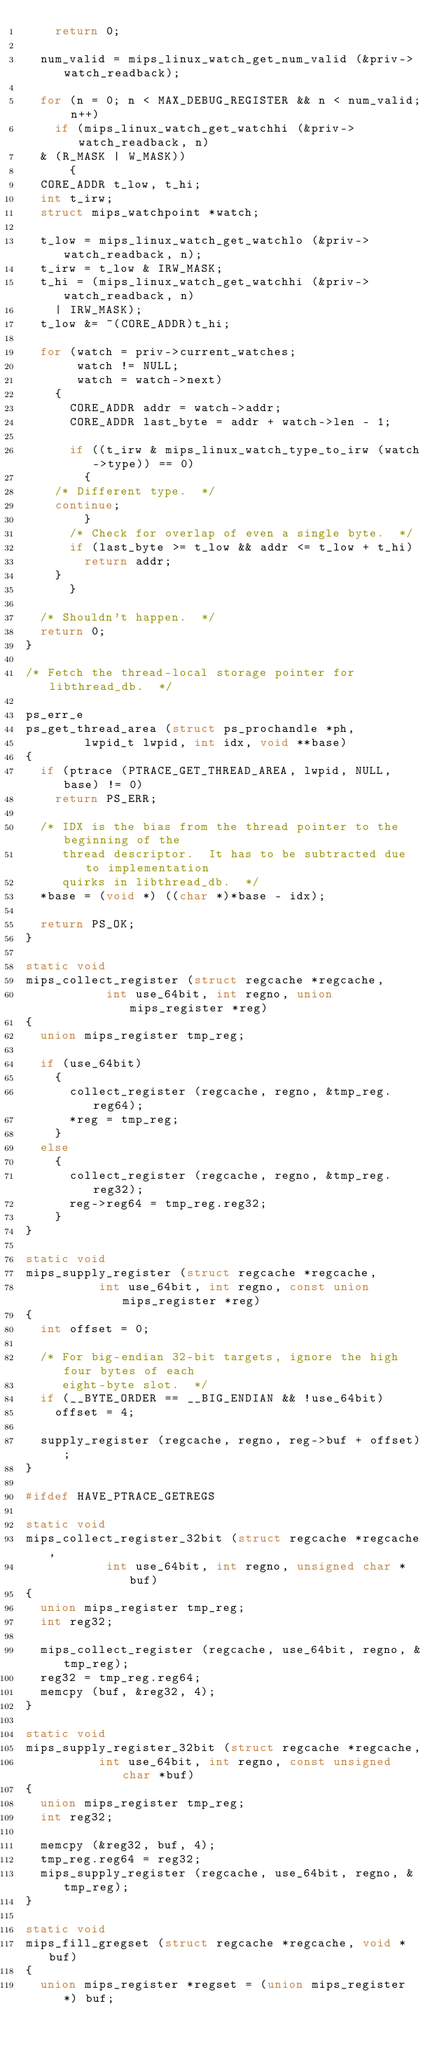<code> <loc_0><loc_0><loc_500><loc_500><_C++_>    return 0;

  num_valid = mips_linux_watch_get_num_valid (&priv->watch_readback);

  for (n = 0; n < MAX_DEBUG_REGISTER && n < num_valid; n++)
    if (mips_linux_watch_get_watchhi (&priv->watch_readback, n)
	& (R_MASK | W_MASK))
      {
	CORE_ADDR t_low, t_hi;
	int t_irw;
	struct mips_watchpoint *watch;

	t_low = mips_linux_watch_get_watchlo (&priv->watch_readback, n);
	t_irw = t_low & IRW_MASK;
	t_hi = (mips_linux_watch_get_watchhi (&priv->watch_readback, n)
		| IRW_MASK);
	t_low &= ~(CORE_ADDR)t_hi;

	for (watch = priv->current_watches;
	     watch != NULL;
	     watch = watch->next)
	  {
	    CORE_ADDR addr = watch->addr;
	    CORE_ADDR last_byte = addr + watch->len - 1;

	    if ((t_irw & mips_linux_watch_type_to_irw (watch->type)) == 0)
	      {
		/* Different type.  */
		continue;
	      }
	    /* Check for overlap of even a single byte.  */
	    if (last_byte >= t_low && addr <= t_low + t_hi)
	      return addr;
	  }
      }

  /* Shouldn't happen.  */
  return 0;
}

/* Fetch the thread-local storage pointer for libthread_db.  */

ps_err_e
ps_get_thread_area (struct ps_prochandle *ph,
		    lwpid_t lwpid, int idx, void **base)
{
  if (ptrace (PTRACE_GET_THREAD_AREA, lwpid, NULL, base) != 0)
    return PS_ERR;

  /* IDX is the bias from the thread pointer to the beginning of the
     thread descriptor.  It has to be subtracted due to implementation
     quirks in libthread_db.  */
  *base = (void *) ((char *)*base - idx);

  return PS_OK;
}

static void
mips_collect_register (struct regcache *regcache,
		       int use_64bit, int regno, union mips_register *reg)
{
  union mips_register tmp_reg;

  if (use_64bit)
    {
      collect_register (regcache, regno, &tmp_reg.reg64);
      *reg = tmp_reg;
    }
  else
    {
      collect_register (regcache, regno, &tmp_reg.reg32);
      reg->reg64 = tmp_reg.reg32;
    }
}

static void
mips_supply_register (struct regcache *regcache,
		      int use_64bit, int regno, const union mips_register *reg)
{
  int offset = 0;

  /* For big-endian 32-bit targets, ignore the high four bytes of each
     eight-byte slot.  */
  if (__BYTE_ORDER == __BIG_ENDIAN && !use_64bit)
    offset = 4;

  supply_register (regcache, regno, reg->buf + offset);
}

#ifdef HAVE_PTRACE_GETREGS

static void
mips_collect_register_32bit (struct regcache *regcache,
			     int use_64bit, int regno, unsigned char *buf)
{
  union mips_register tmp_reg;
  int reg32;

  mips_collect_register (regcache, use_64bit, regno, &tmp_reg);
  reg32 = tmp_reg.reg64;
  memcpy (buf, &reg32, 4);
}

static void
mips_supply_register_32bit (struct regcache *regcache,
			    int use_64bit, int regno, const unsigned char *buf)
{
  union mips_register tmp_reg;
  int reg32;

  memcpy (&reg32, buf, 4);
  tmp_reg.reg64 = reg32;
  mips_supply_register (regcache, use_64bit, regno, &tmp_reg);
}

static void
mips_fill_gregset (struct regcache *regcache, void *buf)
{
  union mips_register *regset = (union mips_register *) buf;</code> 